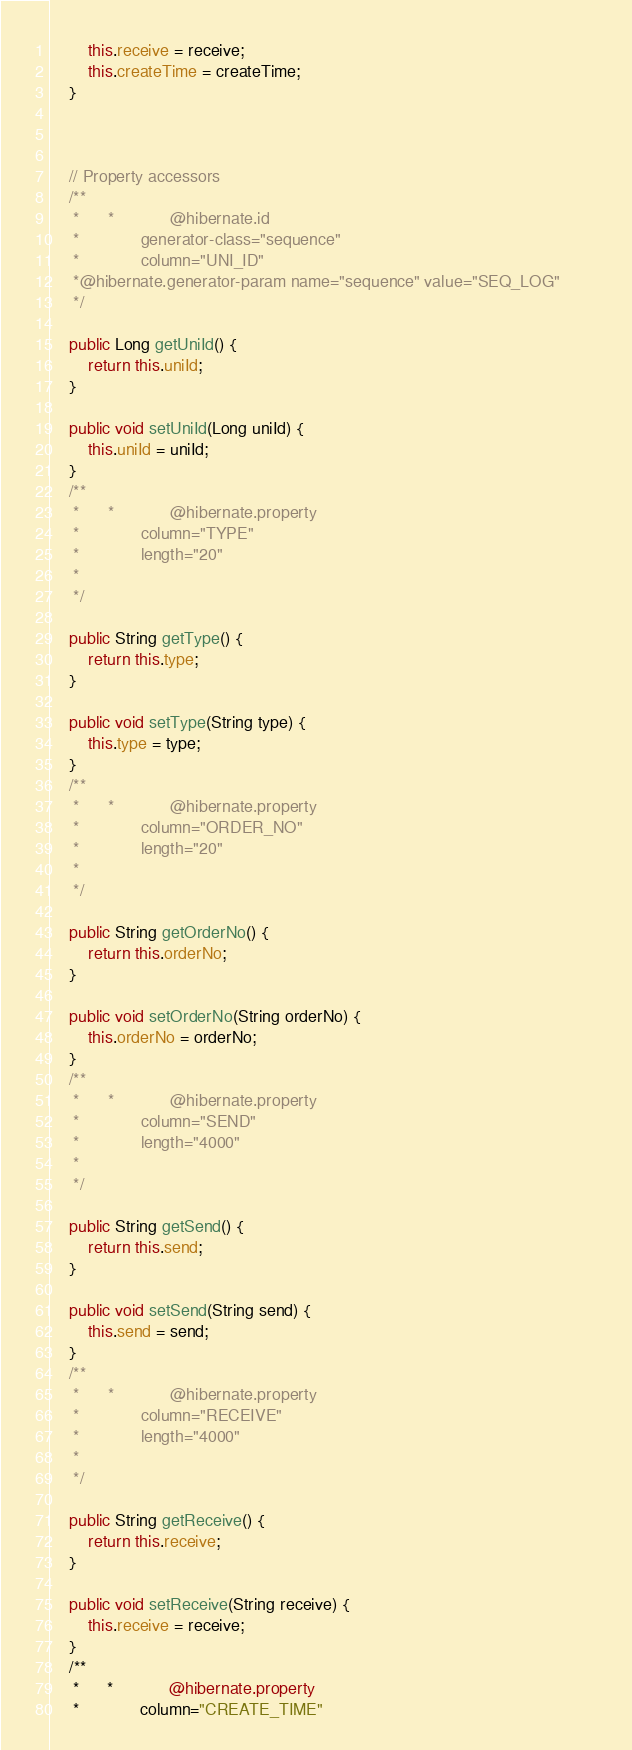Convert code to text. <code><loc_0><loc_0><loc_500><loc_500><_Java_>        this.receive = receive;
        this.createTime = createTime;
    }
    

   
    // Property accessors
    /**       
     *      *            @hibernate.id
     *             generator-class="sequence"
     *             column="UNI_ID"
     *@hibernate.generator-param name="sequence" value="SEQ_LOG"        
     */

    public Long getUniId() {
        return this.uniId;
    }
    
    public void setUniId(Long uniId) {
        this.uniId = uniId;
    }
    /**       
     *      *            @hibernate.property
     *             column="TYPE"
     *             length="20"
     *         
     */

    public String getType() {
        return this.type;
    }
    
    public void setType(String type) {
        this.type = type;
    }
    /**       
     *      *            @hibernate.property
     *             column="ORDER_NO"
     *             length="20"
     *         
     */

    public String getOrderNo() {
        return this.orderNo;
    }
    
    public void setOrderNo(String orderNo) {
        this.orderNo = orderNo;
    }
    /**       
     *      *            @hibernate.property
     *             column="SEND"
     *             length="4000"
     *         
     */

    public String getSend() {
        return this.send;
    }
    
    public void setSend(String send) {
        this.send = send;
    }
    /**       
     *      *            @hibernate.property
     *             column="RECEIVE"
     *             length="4000"
     *         
     */

    public String getReceive() {
        return this.receive;
    }
    
    public void setReceive(String receive) {
        this.receive = receive;
    }
    /**       
     *      *            @hibernate.property
     *             column="CREATE_TIME"</code> 